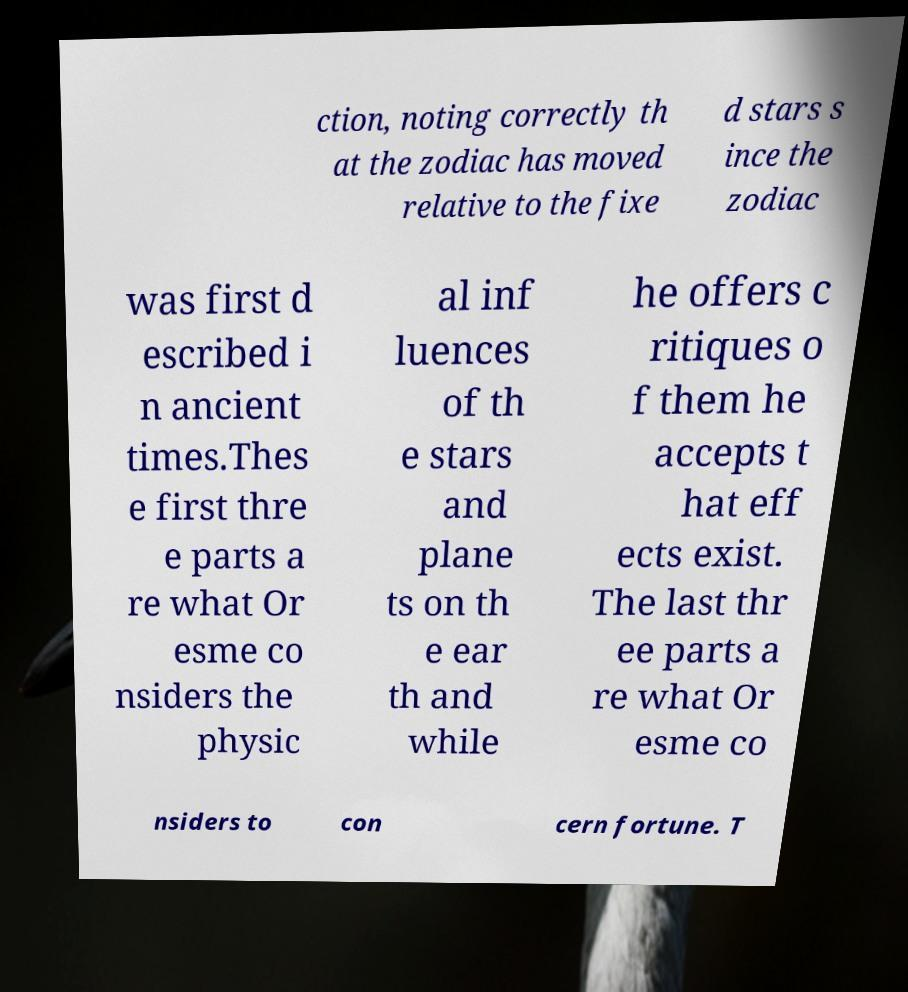Please read and relay the text visible in this image. What does it say? ction, noting correctly th at the zodiac has moved relative to the fixe d stars s ince the zodiac was first d escribed i n ancient times.Thes e first thre e parts a re what Or esme co nsiders the physic al inf luences of th e stars and plane ts on th e ear th and while he offers c ritiques o f them he accepts t hat eff ects exist. The last thr ee parts a re what Or esme co nsiders to con cern fortune. T 